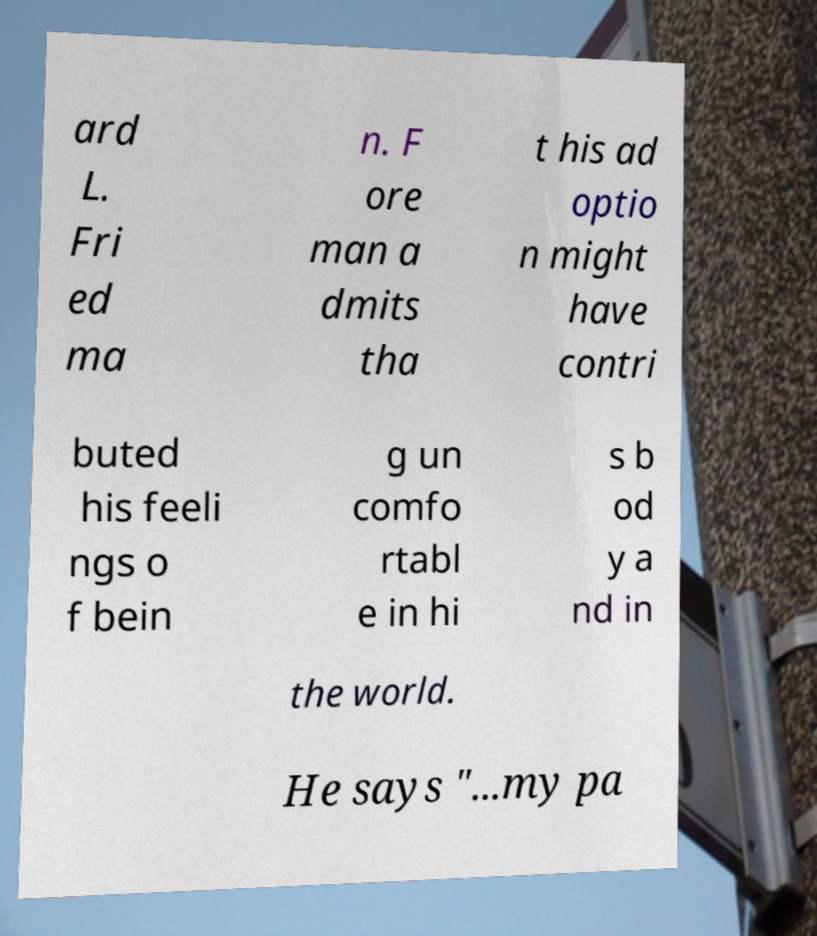Can you read and provide the text displayed in the image?This photo seems to have some interesting text. Can you extract and type it out for me? ard L. Fri ed ma n. F ore man a dmits tha t his ad optio n might have contri buted his feeli ngs o f bein g un comfo rtabl e in hi s b od y a nd in the world. He says "...my pa 